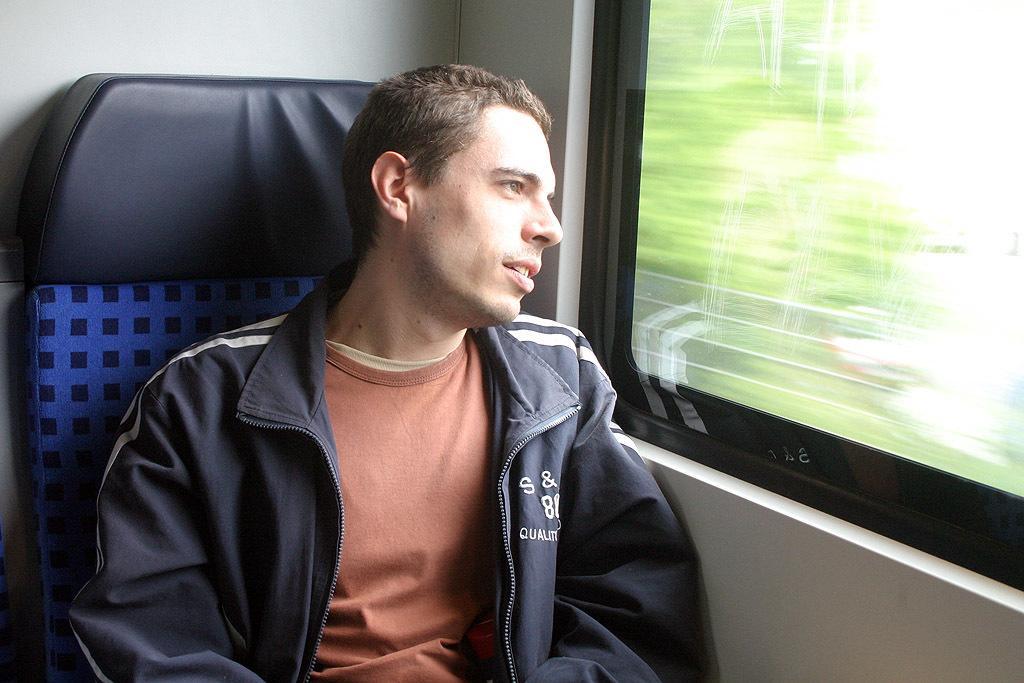Please provide a concise description of this image. In this picture there is a man sitting on a seat and we can see glass window, through this glass window we can see blur view. 